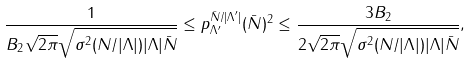<formula> <loc_0><loc_0><loc_500><loc_500>\frac { 1 } { B _ { 2 } \sqrt { 2 \pi } \sqrt { \sigma ^ { 2 } ( N / | \Lambda | ) | \Lambda | \bar { N } } } \leq p _ { \Lambda ^ { \prime } } ^ { \bar { N } / | \Lambda ^ { \prime } | } ( \bar { N } ) ^ { 2 } \leq \frac { 3 B _ { 2 } } { 2 \sqrt { 2 \pi } \sqrt { \sigma ^ { 2 } ( N / | \Lambda | ) | \Lambda | \bar { N } } } ,</formula> 